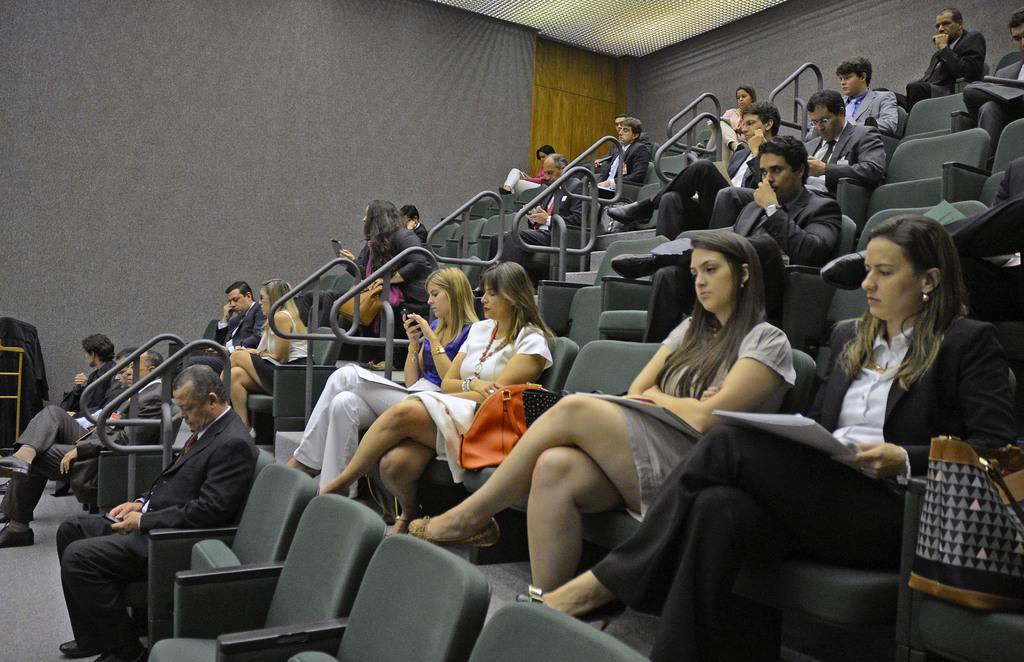In one or two sentences, can you explain what this image depicts? In this image I can see number of persons are sitting on chairs which are black in color and the railing. In the background I can see the grey colored wall, the cream colored ceiling and the brown colored surface. 